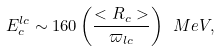Convert formula to latex. <formula><loc_0><loc_0><loc_500><loc_500>E _ { c } ^ { l c } \sim 1 6 0 \left ( \frac { < R _ { c } > } { \varpi _ { l c } } \right ) \ M e V ,</formula> 